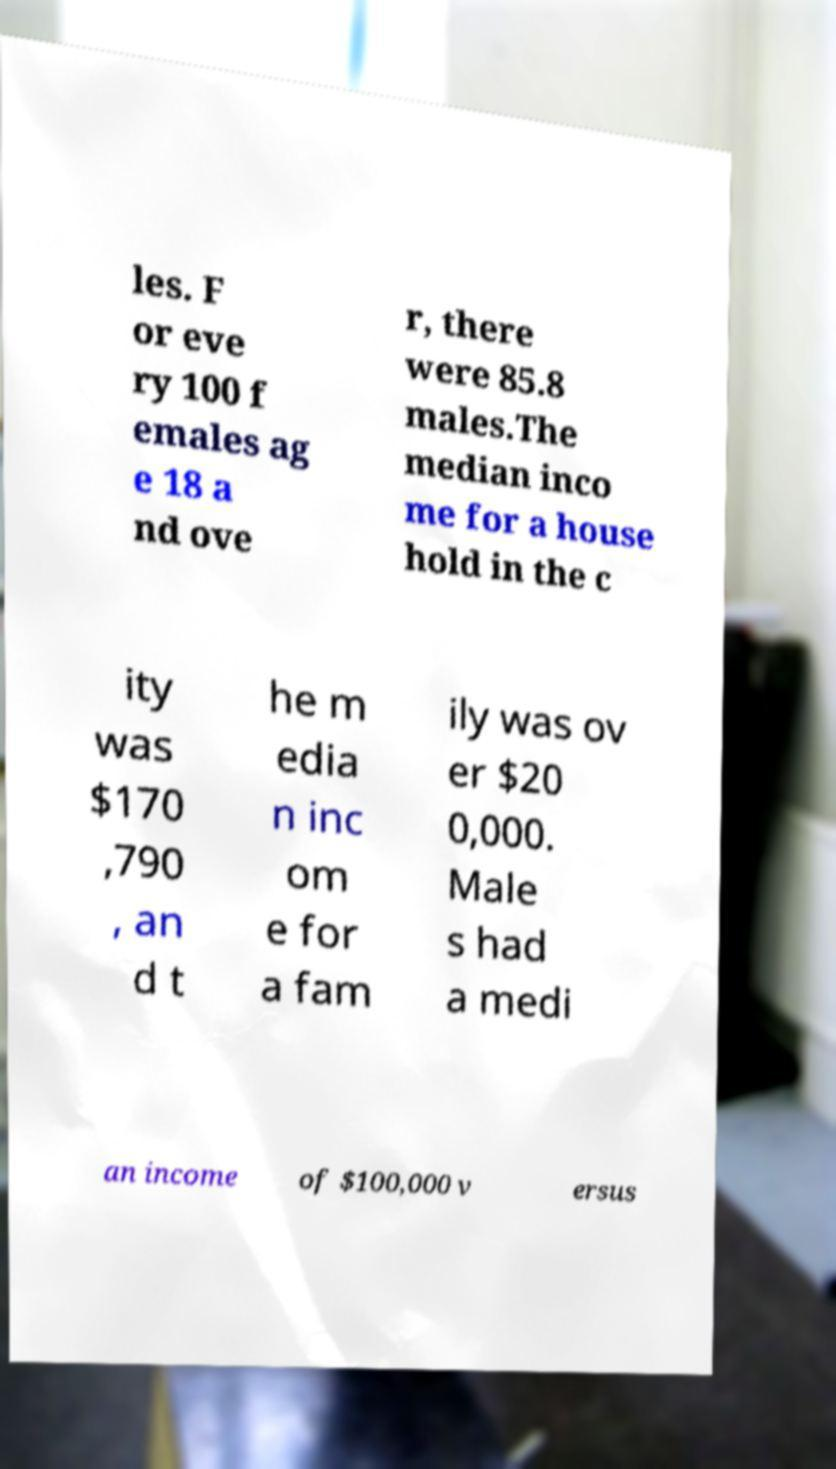Please identify and transcribe the text found in this image. les. F or eve ry 100 f emales ag e 18 a nd ove r, there were 85.8 males.The median inco me for a house hold in the c ity was $170 ,790 , an d t he m edia n inc om e for a fam ily was ov er $20 0,000. Male s had a medi an income of $100,000 v ersus 